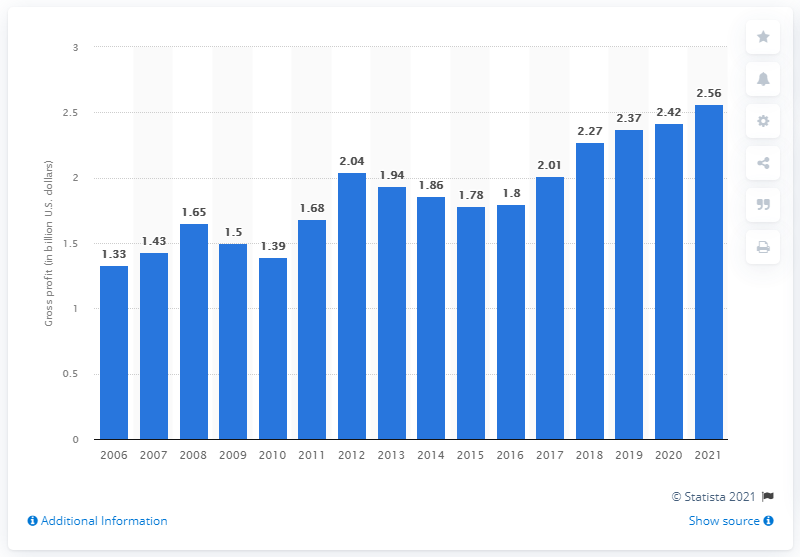Draw attention to some important aspects in this diagram. In the fiscal year 2021, the worldwide gross profit of Bandai Namco Holdings was 2.56 billion dollars. 